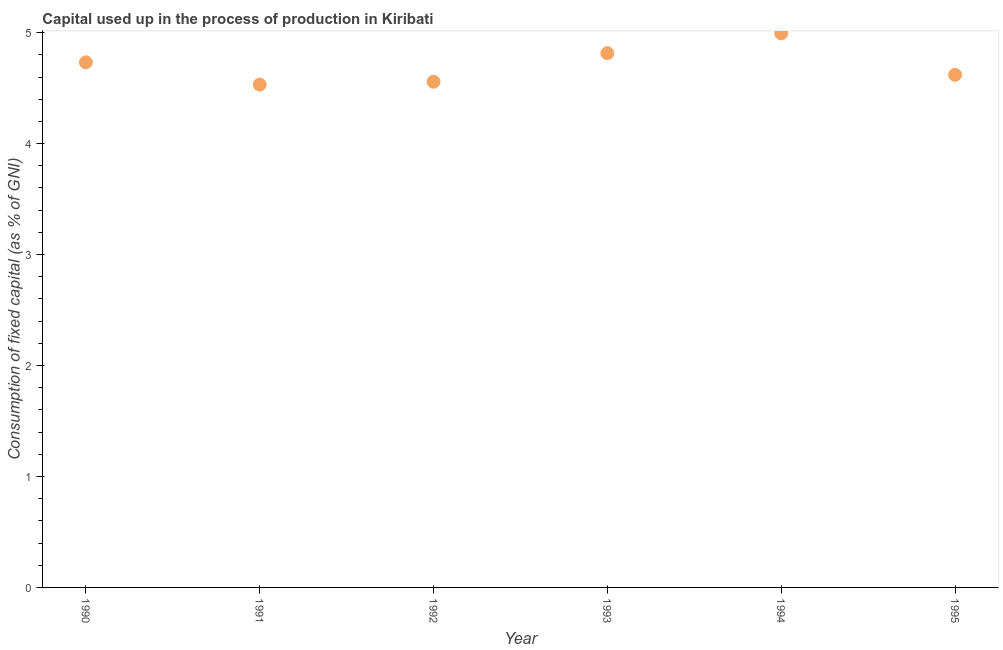What is the consumption of fixed capital in 1990?
Your response must be concise. 4.73. Across all years, what is the maximum consumption of fixed capital?
Offer a terse response. 4.99. Across all years, what is the minimum consumption of fixed capital?
Make the answer very short. 4.53. What is the sum of the consumption of fixed capital?
Your response must be concise. 28.25. What is the difference between the consumption of fixed capital in 1990 and 1991?
Offer a very short reply. 0.2. What is the average consumption of fixed capital per year?
Provide a succinct answer. 4.71. What is the median consumption of fixed capital?
Keep it short and to the point. 4.68. In how many years, is the consumption of fixed capital greater than 4.8 %?
Your response must be concise. 2. What is the ratio of the consumption of fixed capital in 1990 to that in 1995?
Your answer should be very brief. 1.02. Is the consumption of fixed capital in 1990 less than that in 1992?
Give a very brief answer. No. Is the difference between the consumption of fixed capital in 1990 and 1991 greater than the difference between any two years?
Provide a short and direct response. No. What is the difference between the highest and the second highest consumption of fixed capital?
Make the answer very short. 0.18. Is the sum of the consumption of fixed capital in 1990 and 1994 greater than the maximum consumption of fixed capital across all years?
Your answer should be compact. Yes. What is the difference between the highest and the lowest consumption of fixed capital?
Your answer should be compact. 0.46. In how many years, is the consumption of fixed capital greater than the average consumption of fixed capital taken over all years?
Make the answer very short. 3. Does the consumption of fixed capital monotonically increase over the years?
Provide a short and direct response. No. How many years are there in the graph?
Keep it short and to the point. 6. What is the difference between two consecutive major ticks on the Y-axis?
Your answer should be very brief. 1. Are the values on the major ticks of Y-axis written in scientific E-notation?
Make the answer very short. No. Does the graph contain any zero values?
Your answer should be compact. No. What is the title of the graph?
Offer a terse response. Capital used up in the process of production in Kiribati. What is the label or title of the X-axis?
Make the answer very short. Year. What is the label or title of the Y-axis?
Your answer should be very brief. Consumption of fixed capital (as % of GNI). What is the Consumption of fixed capital (as % of GNI) in 1990?
Provide a short and direct response. 4.73. What is the Consumption of fixed capital (as % of GNI) in 1991?
Your answer should be compact. 4.53. What is the Consumption of fixed capital (as % of GNI) in 1992?
Provide a short and direct response. 4.56. What is the Consumption of fixed capital (as % of GNI) in 1993?
Your response must be concise. 4.81. What is the Consumption of fixed capital (as % of GNI) in 1994?
Offer a very short reply. 4.99. What is the Consumption of fixed capital (as % of GNI) in 1995?
Ensure brevity in your answer.  4.62. What is the difference between the Consumption of fixed capital (as % of GNI) in 1990 and 1991?
Make the answer very short. 0.2. What is the difference between the Consumption of fixed capital (as % of GNI) in 1990 and 1992?
Keep it short and to the point. 0.18. What is the difference between the Consumption of fixed capital (as % of GNI) in 1990 and 1993?
Ensure brevity in your answer.  -0.08. What is the difference between the Consumption of fixed capital (as % of GNI) in 1990 and 1994?
Give a very brief answer. -0.26. What is the difference between the Consumption of fixed capital (as % of GNI) in 1990 and 1995?
Provide a succinct answer. 0.11. What is the difference between the Consumption of fixed capital (as % of GNI) in 1991 and 1992?
Provide a succinct answer. -0.03. What is the difference between the Consumption of fixed capital (as % of GNI) in 1991 and 1993?
Offer a very short reply. -0.28. What is the difference between the Consumption of fixed capital (as % of GNI) in 1991 and 1994?
Ensure brevity in your answer.  -0.46. What is the difference between the Consumption of fixed capital (as % of GNI) in 1991 and 1995?
Keep it short and to the point. -0.09. What is the difference between the Consumption of fixed capital (as % of GNI) in 1992 and 1993?
Your answer should be very brief. -0.26. What is the difference between the Consumption of fixed capital (as % of GNI) in 1992 and 1994?
Offer a terse response. -0.44. What is the difference between the Consumption of fixed capital (as % of GNI) in 1992 and 1995?
Keep it short and to the point. -0.06. What is the difference between the Consumption of fixed capital (as % of GNI) in 1993 and 1994?
Your answer should be compact. -0.18. What is the difference between the Consumption of fixed capital (as % of GNI) in 1993 and 1995?
Provide a succinct answer. 0.19. What is the difference between the Consumption of fixed capital (as % of GNI) in 1994 and 1995?
Give a very brief answer. 0.37. What is the ratio of the Consumption of fixed capital (as % of GNI) in 1990 to that in 1991?
Offer a very short reply. 1.04. What is the ratio of the Consumption of fixed capital (as % of GNI) in 1990 to that in 1992?
Your answer should be compact. 1.04. What is the ratio of the Consumption of fixed capital (as % of GNI) in 1990 to that in 1994?
Offer a terse response. 0.95. What is the ratio of the Consumption of fixed capital (as % of GNI) in 1991 to that in 1992?
Your response must be concise. 0.99. What is the ratio of the Consumption of fixed capital (as % of GNI) in 1991 to that in 1993?
Keep it short and to the point. 0.94. What is the ratio of the Consumption of fixed capital (as % of GNI) in 1991 to that in 1994?
Your response must be concise. 0.91. What is the ratio of the Consumption of fixed capital (as % of GNI) in 1992 to that in 1993?
Ensure brevity in your answer.  0.95. What is the ratio of the Consumption of fixed capital (as % of GNI) in 1992 to that in 1994?
Your answer should be very brief. 0.91. What is the ratio of the Consumption of fixed capital (as % of GNI) in 1993 to that in 1994?
Your response must be concise. 0.96. What is the ratio of the Consumption of fixed capital (as % of GNI) in 1993 to that in 1995?
Offer a terse response. 1.04. What is the ratio of the Consumption of fixed capital (as % of GNI) in 1994 to that in 1995?
Make the answer very short. 1.08. 